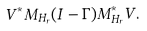<formula> <loc_0><loc_0><loc_500><loc_500>V ^ { * } M _ { H _ { r } } ( I - \Gamma ) M _ { H _ { r } } ^ { * } V .</formula> 